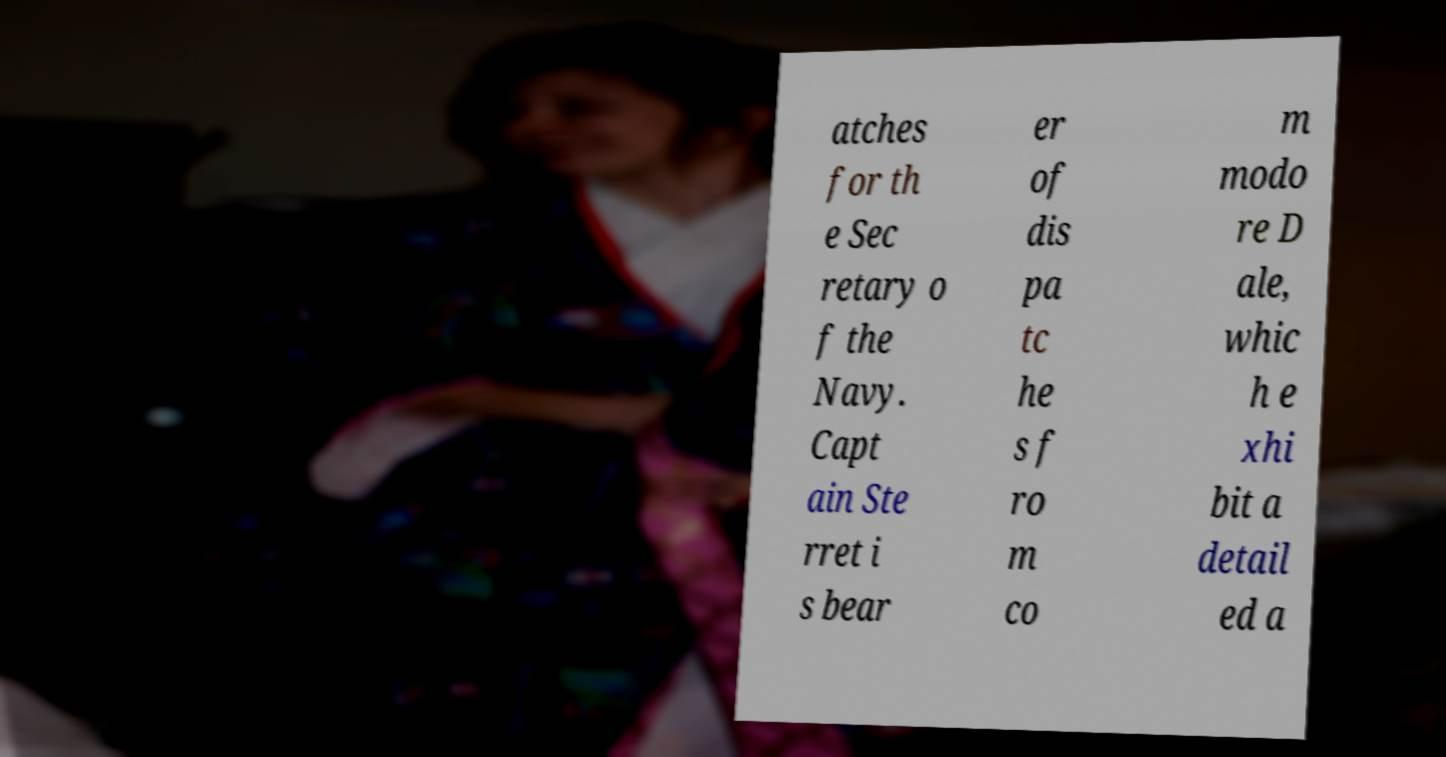Please read and relay the text visible in this image. What does it say? atches for th e Sec retary o f the Navy. Capt ain Ste rret i s bear er of dis pa tc he s f ro m co m modo re D ale, whic h e xhi bit a detail ed a 